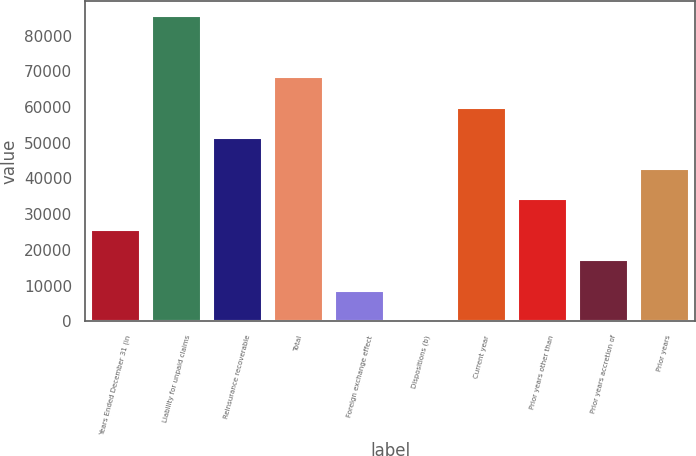Convert chart to OTSL. <chart><loc_0><loc_0><loc_500><loc_500><bar_chart><fcel>Years Ended December 31 (in<fcel>Liability for unpaid claims<fcel>Reinsurance recoverable<fcel>Total<fcel>Foreign exchange effect<fcel>Dispositions (b)<fcel>Current year<fcel>Prior years other than<fcel>Prior years accretion of<fcel>Prior years<nl><fcel>25676.7<fcel>85386<fcel>51266.4<fcel>68326.2<fcel>8616.9<fcel>87<fcel>59796.3<fcel>34206.6<fcel>17146.8<fcel>42736.5<nl></chart> 